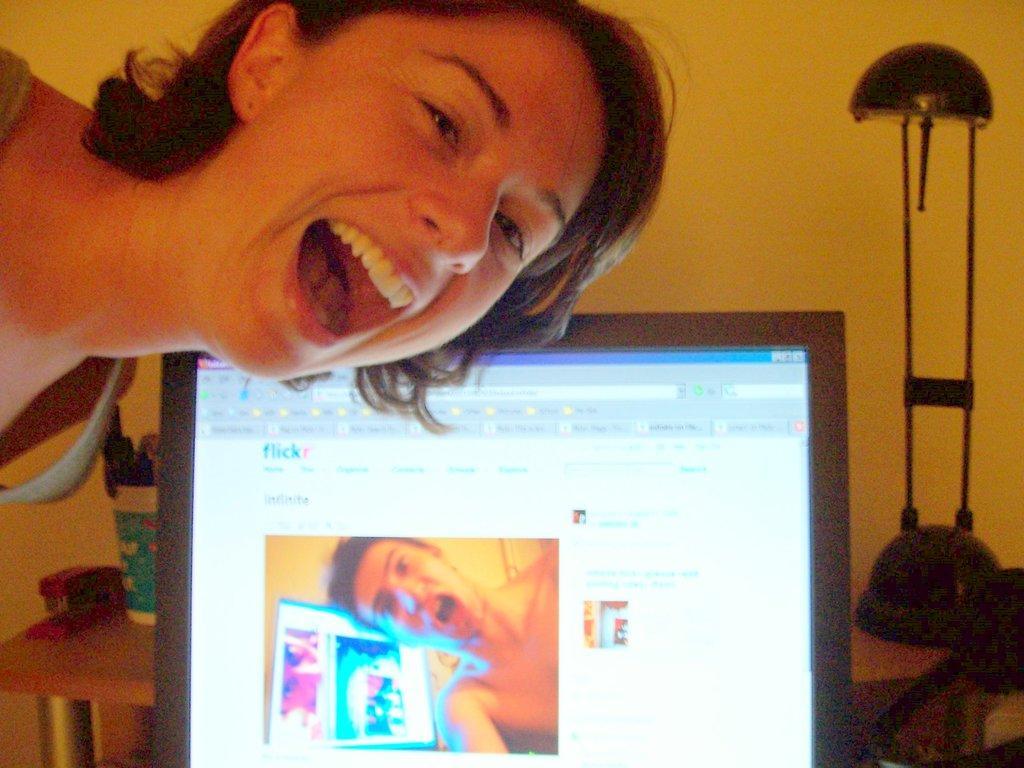In one or two sentences, can you explain what this image depicts? In this image there is a woman who is laughing by opening her mouth. In the background there is a screen. Behind the screen there is a table on which there are buckets,stand and a lamp. 